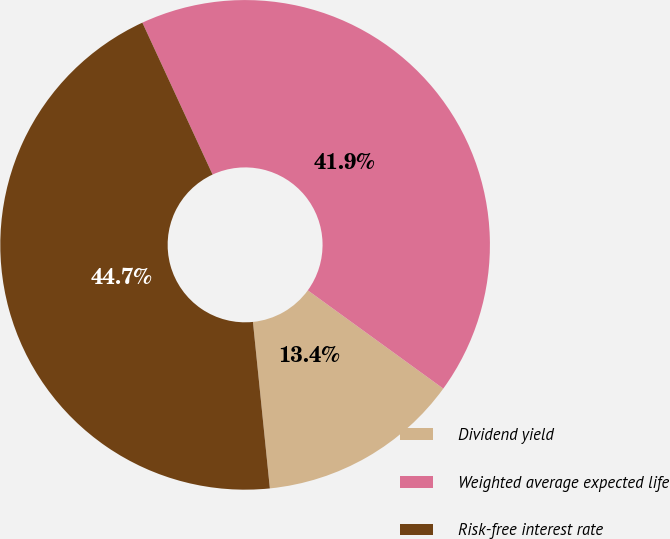Convert chart. <chart><loc_0><loc_0><loc_500><loc_500><pie_chart><fcel>Dividend yield<fcel>Weighted average expected life<fcel>Risk-free interest rate<nl><fcel>13.4%<fcel>41.88%<fcel>44.72%<nl></chart> 